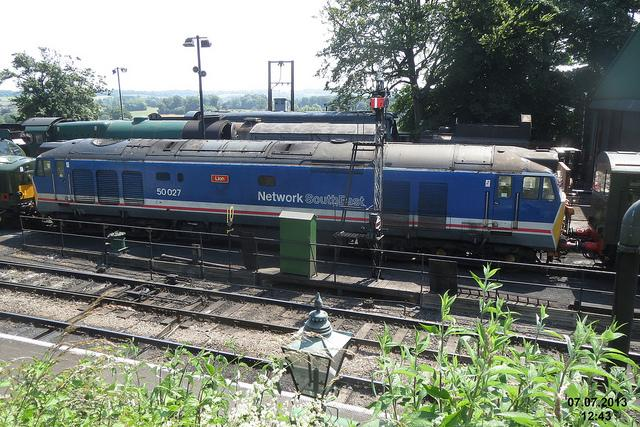What is the first number that appears on the train?

Choices:
A) five
B) seven
C) eight
D) nine five 